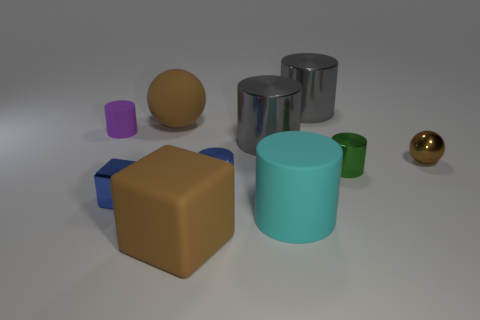Is there any other thing that is the same size as the blue metal cylinder? After observing the relative sizes of the objects in the image, it appears that the green cylinder may share a similar height to the blue metal cylinder, though its diameter is smaller. No other object exactly matches the size of the blue cylinder in both dimensions. 